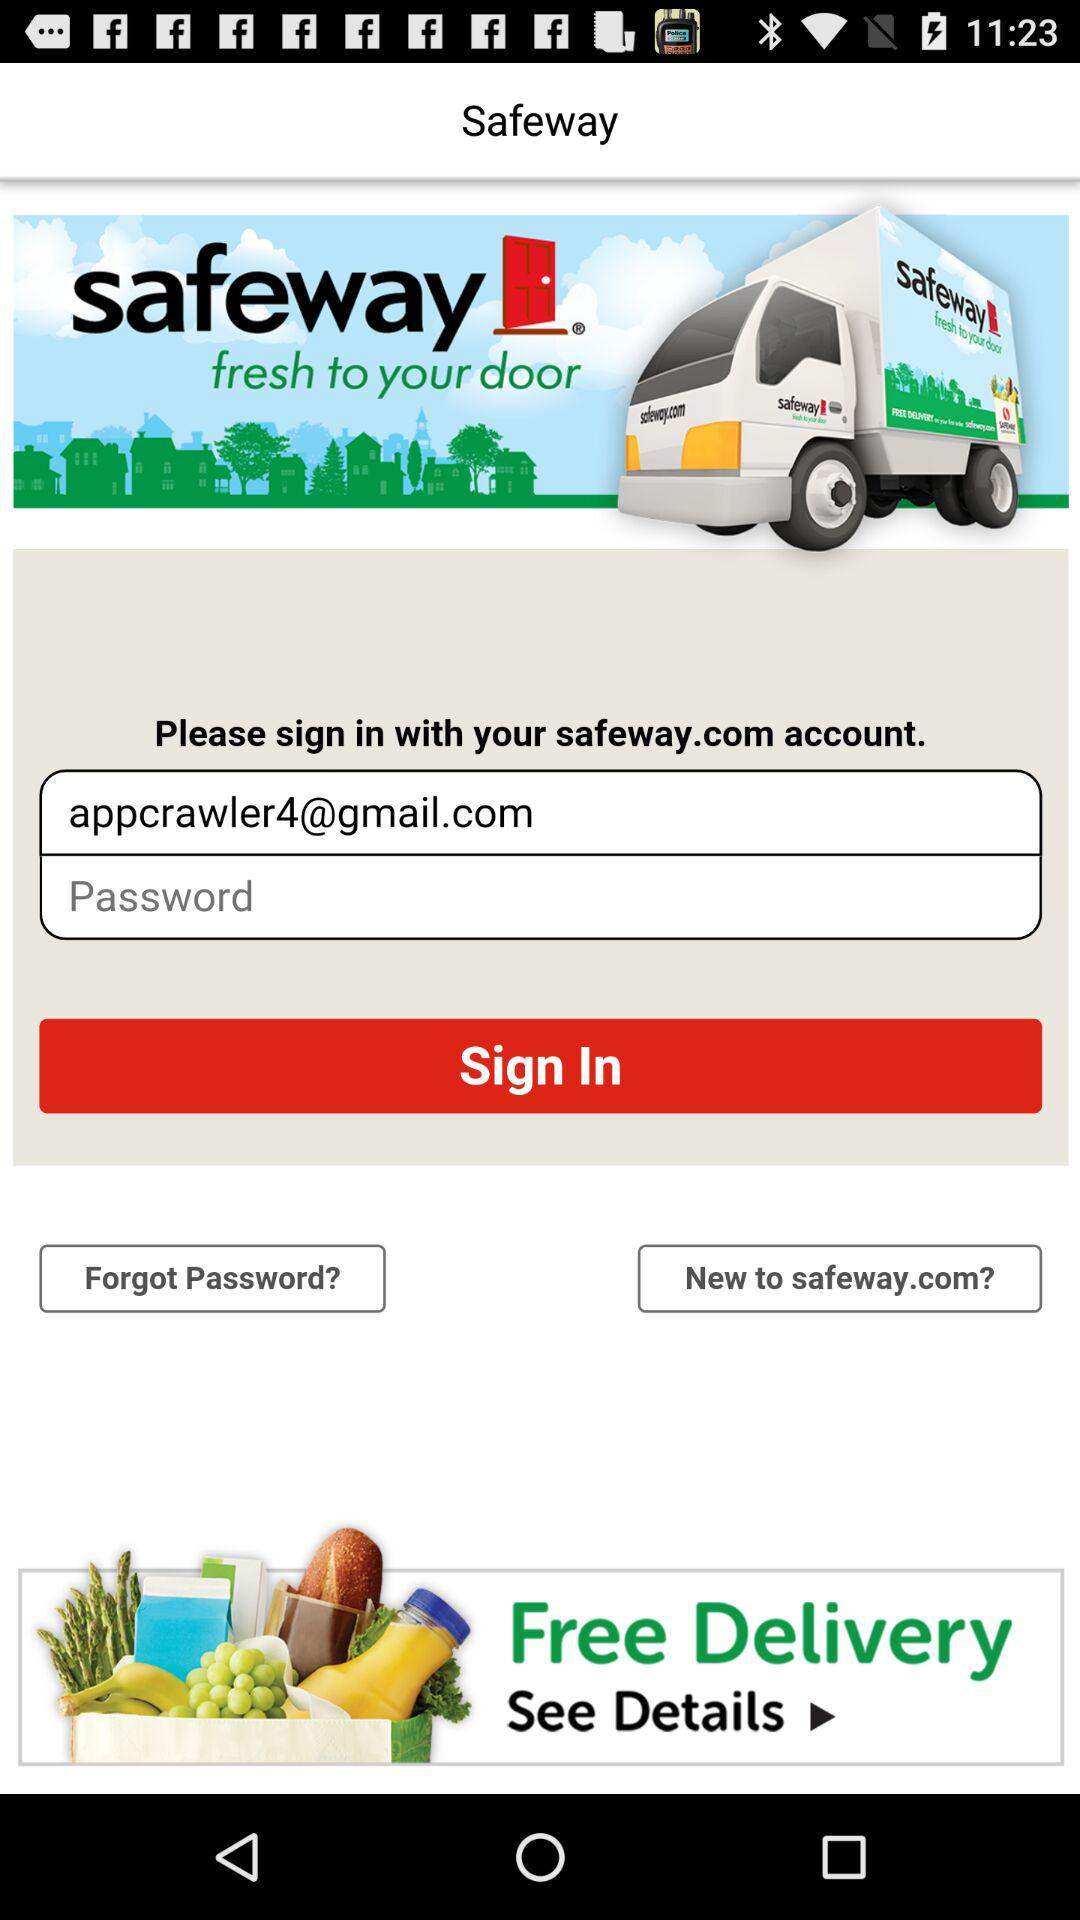What is the name of the application? The name of the application is "Safeway". 